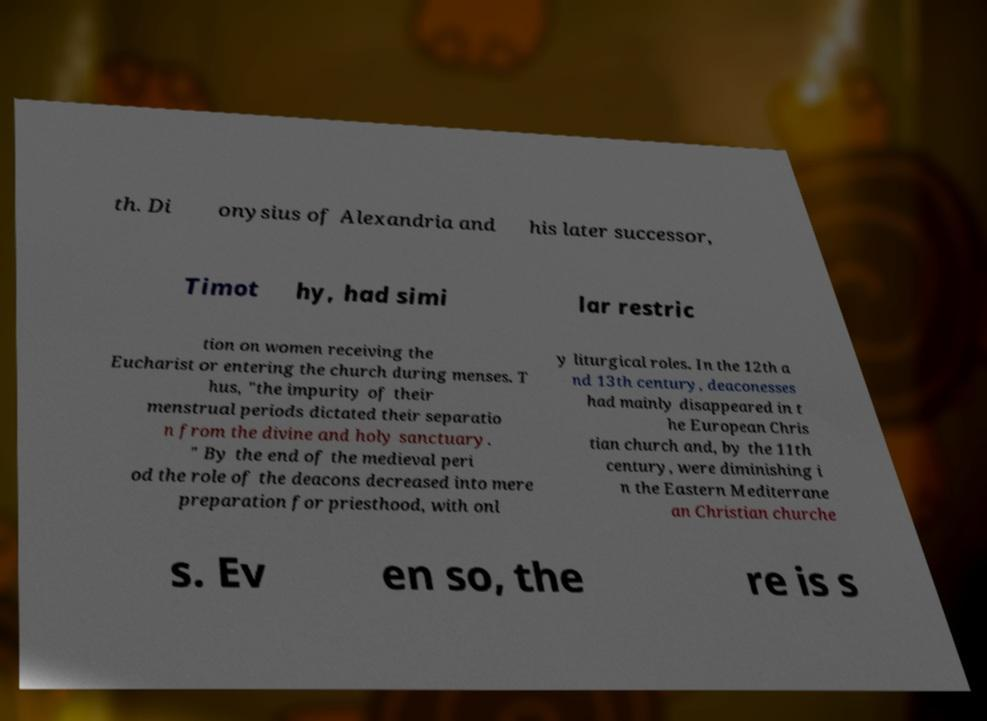What messages or text are displayed in this image? I need them in a readable, typed format. th. Di onysius of Alexandria and his later successor, Timot hy, had simi lar restric tion on women receiving the Eucharist or entering the church during menses. T hus, "the impurity of their menstrual periods dictated their separatio n from the divine and holy sanctuary. " By the end of the medieval peri od the role of the deacons decreased into mere preparation for priesthood, with onl y liturgical roles. In the 12th a nd 13th century, deaconesses had mainly disappeared in t he European Chris tian church and, by the 11th century, were diminishing i n the Eastern Mediterrane an Christian churche s. Ev en so, the re is s 